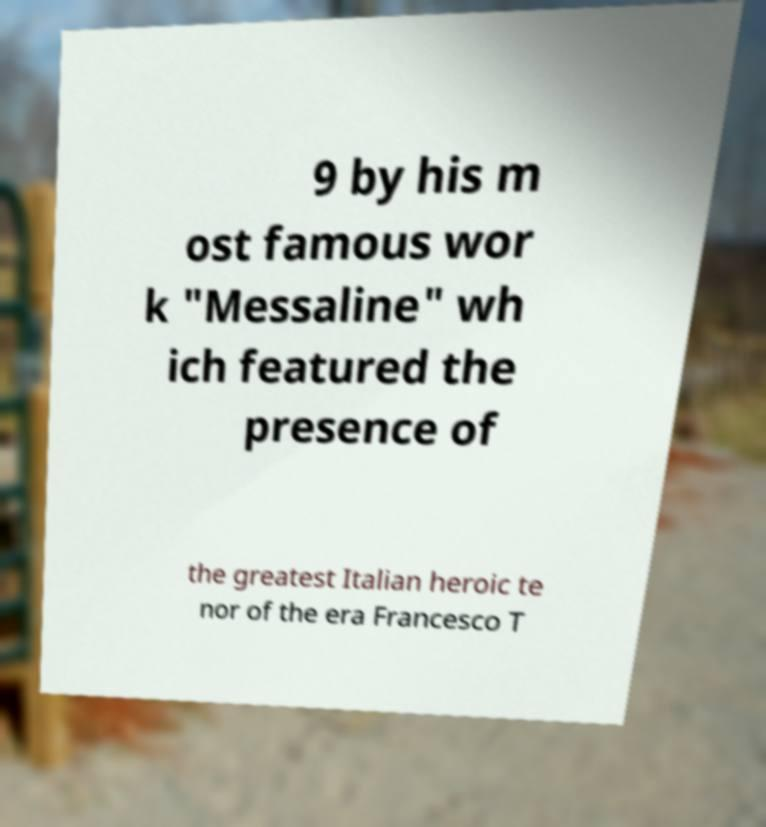Please read and relay the text visible in this image. What does it say? 9 by his m ost famous wor k "Messaline" wh ich featured the presence of the greatest Italian heroic te nor of the era Francesco T 